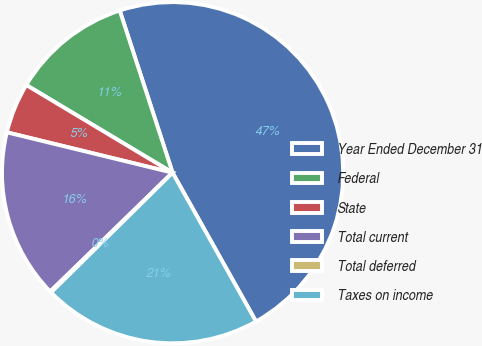Convert chart. <chart><loc_0><loc_0><loc_500><loc_500><pie_chart><fcel>Year Ended December 31<fcel>Federal<fcel>State<fcel>Total current<fcel>Total deferred<fcel>Taxes on income<nl><fcel>46.88%<fcel>11.39%<fcel>4.79%<fcel>16.07%<fcel>0.12%<fcel>20.75%<nl></chart> 